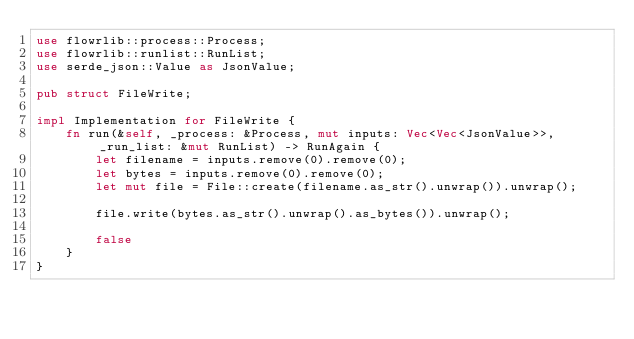Convert code to text. <code><loc_0><loc_0><loc_500><loc_500><_Rust_>use flowrlib::process::Process;
use flowrlib::runlist::RunList;
use serde_json::Value as JsonValue;

pub struct FileWrite;

impl Implementation for FileWrite {
    fn run(&self, _process: &Process, mut inputs: Vec<Vec<JsonValue>>, _run_list: &mut RunList) -> RunAgain {
        let filename = inputs.remove(0).remove(0);
        let bytes = inputs.remove(0).remove(0);
        let mut file = File::create(filename.as_str().unwrap()).unwrap();

        file.write(bytes.as_str().unwrap().as_bytes()).unwrap();

        false
    }
}</code> 